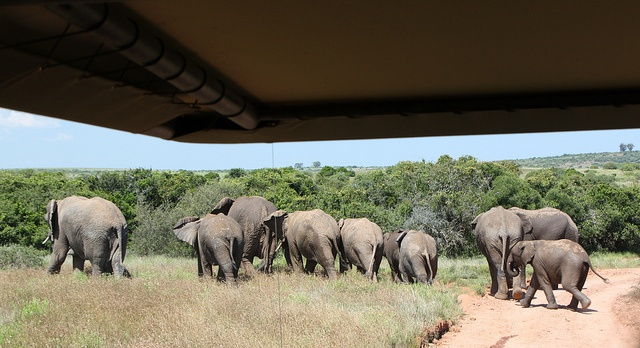Describe the objects in this image and their specific colors. I can see elephant in black, darkgray, gray, and lightgray tones, elephant in black, darkgray, and gray tones, elephant in black, darkgray, gray, and tan tones, elephant in black, darkgray, and gray tones, and elephant in black, darkgray, tan, and gray tones in this image. 